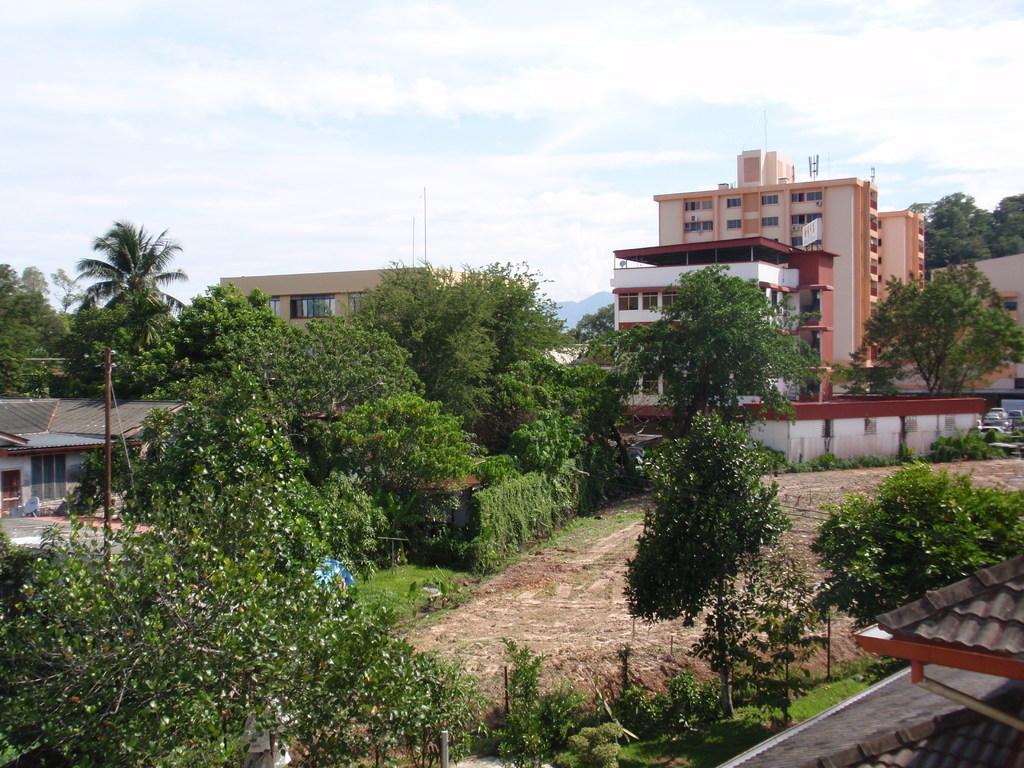Can you describe this image briefly? This picture is taken from the outside of the city. In this image, in the right corner, we can see a house. On the right side, we can see some trees, vehicles, building. On the left side, we can also see some houses, trees, electric pole, electric wires, plants, building, glass window. In the background, we can also see a wall, houses, trees, building, glass window, mountains, plants. At the top, we can see a sky which is a bit cloudy, at the bottom, we can see a plant and a land with some stones. 